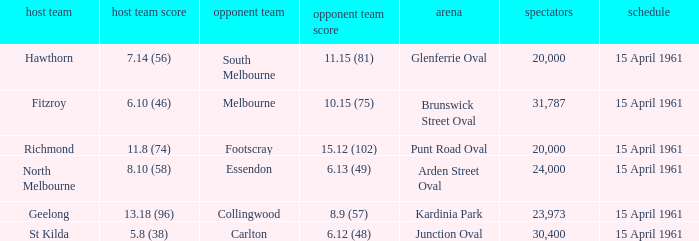Which venue had a home team score of 6.10 (46)? Brunswick Street Oval. 